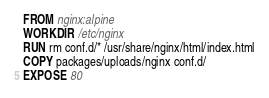<code> <loc_0><loc_0><loc_500><loc_500><_Dockerfile_>FROM nginx:alpine
WORKDIR /etc/nginx
RUN rm conf.d/* /usr/share/nginx/html/index.html
COPY packages/uploads/nginx conf.d/
EXPOSE 80
</code> 